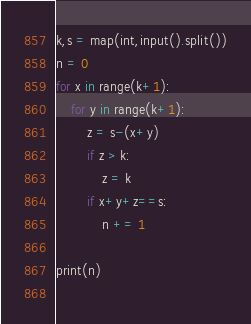Convert code to text. <code><loc_0><loc_0><loc_500><loc_500><_Python_>k,s = map(int,input().split())
n = 0
for x in range(k+1):
    for y in range(k+1):
        z = s-(x+y)
        if z > k:
            z = k
        if x+y+z==s:
            n += 1
                
print(n)
                </code> 